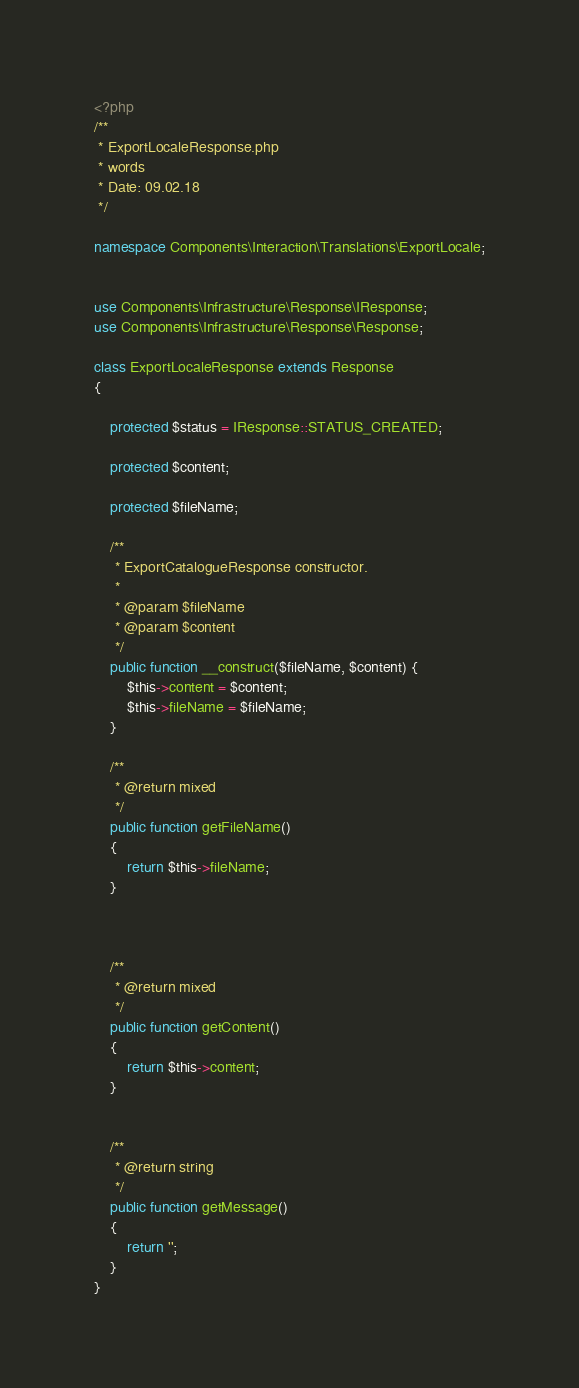<code> <loc_0><loc_0><loc_500><loc_500><_PHP_><?php
/**
 * ExportLocaleResponse.php
 * words
 * Date: 09.02.18
 */

namespace Components\Interaction\Translations\ExportLocale;


use Components\Infrastructure\Response\IResponse;
use Components\Infrastructure\Response\Response;

class ExportLocaleResponse extends Response
{

    protected $status = IResponse::STATUS_CREATED;

    protected $content;

    protected $fileName;

    /**
     * ExportCatalogueResponse constructor.
     *
     * @param $fileName
     * @param $content
     */
    public function __construct($fileName, $content) {
        $this->content = $content;
        $this->fileName = $fileName;
    }

    /**
     * @return mixed
     */
    public function getFileName()
    {
        return $this->fileName;
    }



    /**
     * @return mixed
     */
    public function getContent()
    {
        return $this->content;
    }


    /**
     * @return string
     */
    public function getMessage()
    {
        return '';
    }
}</code> 